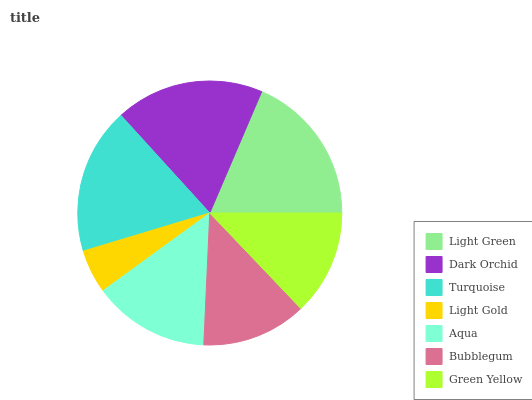Is Light Gold the minimum?
Answer yes or no. Yes. Is Light Green the maximum?
Answer yes or no. Yes. Is Dark Orchid the minimum?
Answer yes or no. No. Is Dark Orchid the maximum?
Answer yes or no. No. Is Light Green greater than Dark Orchid?
Answer yes or no. Yes. Is Dark Orchid less than Light Green?
Answer yes or no. Yes. Is Dark Orchid greater than Light Green?
Answer yes or no. No. Is Light Green less than Dark Orchid?
Answer yes or no. No. Is Aqua the high median?
Answer yes or no. Yes. Is Aqua the low median?
Answer yes or no. Yes. Is Turquoise the high median?
Answer yes or no. No. Is Light Green the low median?
Answer yes or no. No. 